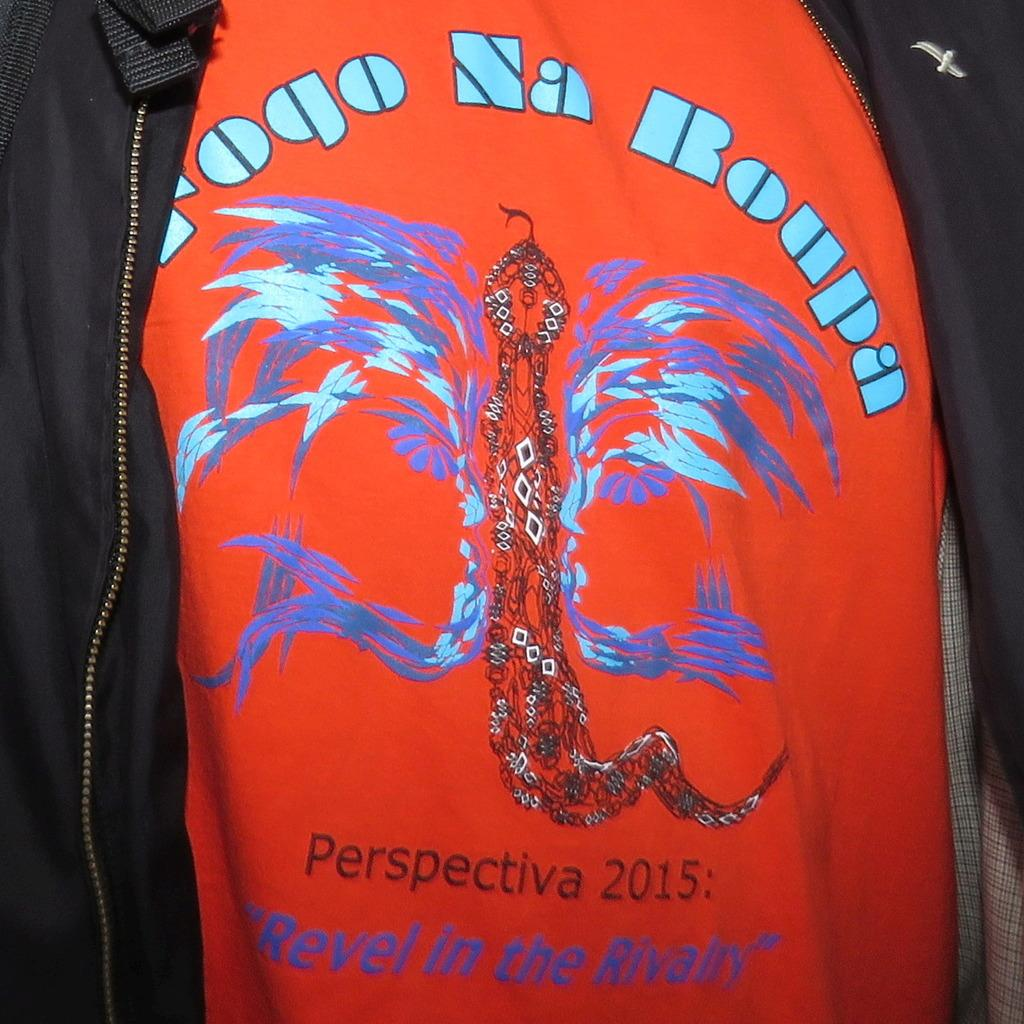What colors are present in the clothes in the image? The clothes in the image have red and black colors. Can you describe the text on the red color cloth? There is text on the red color cloth in the image. What is the baby's name mentioned in the text on the red color cloth? There is no mention of a baby or a name in the text on the red color cloth in the image. 